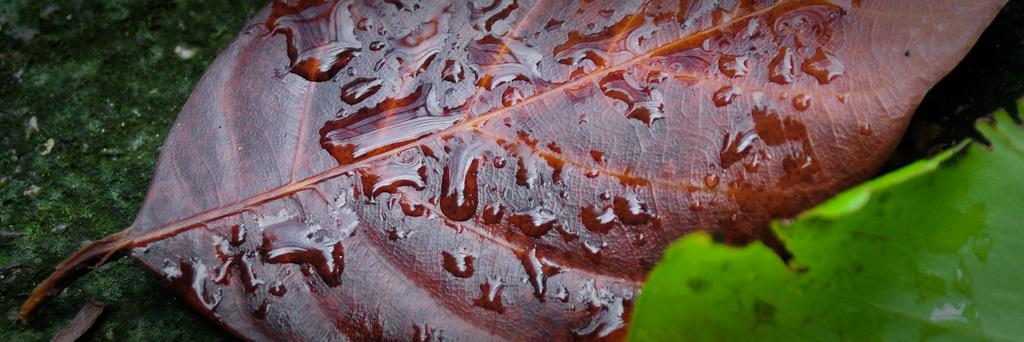How many leaves are visible in the image? There are two leaves in the image. What colors can be seen on the leaves? The leaves have green and brown colors. What is the color of the surface to the left of the image? There is a green color surface to the left of the image. What type of memory does the company offer in the image? There is no mention of a company or memory in the image; it only features two leaves with green and brown colors. 